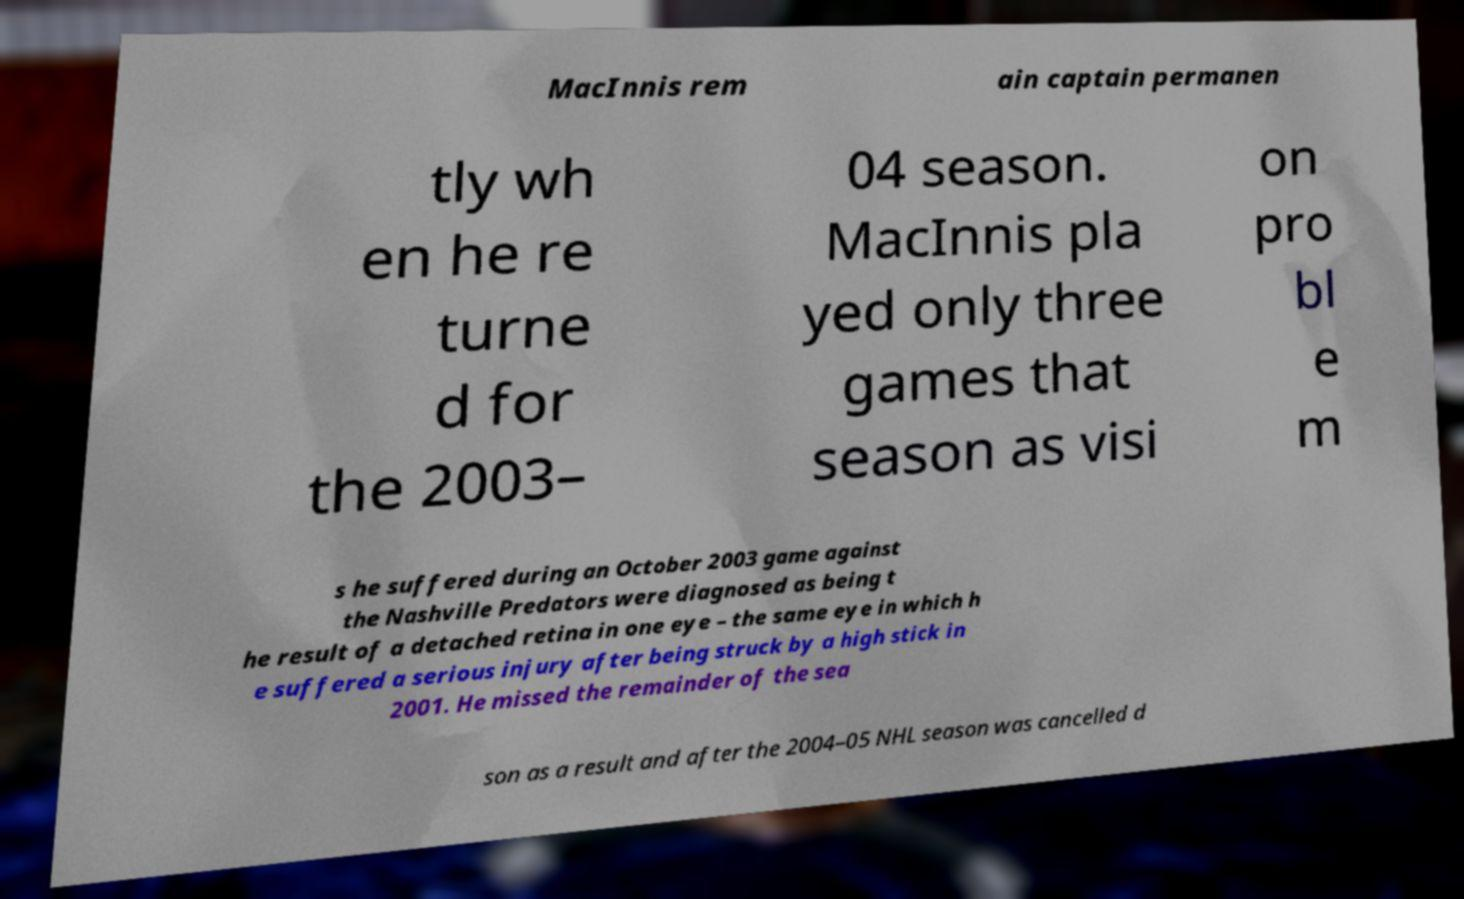I need the written content from this picture converted into text. Can you do that? MacInnis rem ain captain permanen tly wh en he re turne d for the 2003– 04 season. MacInnis pla yed only three games that season as visi on pro bl e m s he suffered during an October 2003 game against the Nashville Predators were diagnosed as being t he result of a detached retina in one eye – the same eye in which h e suffered a serious injury after being struck by a high stick in 2001. He missed the remainder of the sea son as a result and after the 2004–05 NHL season was cancelled d 